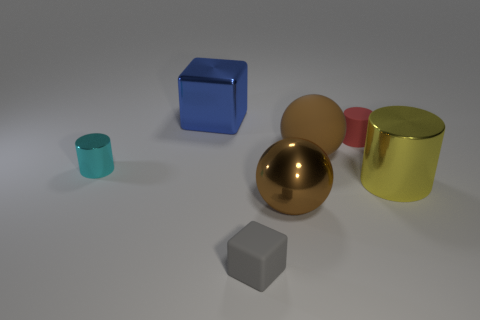There is a small matte thing that is behind the gray cube; does it have the same shape as the big brown thing that is behind the cyan shiny cylinder?
Keep it short and to the point. No. What color is the sphere that is made of the same material as the red object?
Ensure brevity in your answer.  Brown. Are there fewer matte cylinders behind the yellow cylinder than cylinders?
Ensure brevity in your answer.  Yes. There is a block that is left of the matte object in front of the large yellow cylinder to the right of the small cyan metallic cylinder; how big is it?
Make the answer very short. Large. Does the ball that is in front of the yellow metal object have the same material as the large yellow thing?
Offer a terse response. Yes. What material is the large sphere that is the same color as the large rubber thing?
Provide a short and direct response. Metal. What number of things are big brown balls or large yellow metal things?
Provide a succinct answer. 3. The matte thing that is the same shape as the tiny shiny thing is what size?
Ensure brevity in your answer.  Small. How many other things are the same color as the tiny metal thing?
Make the answer very short. 0. How many cylinders are either brown shiny things or brown rubber things?
Offer a very short reply. 0. 